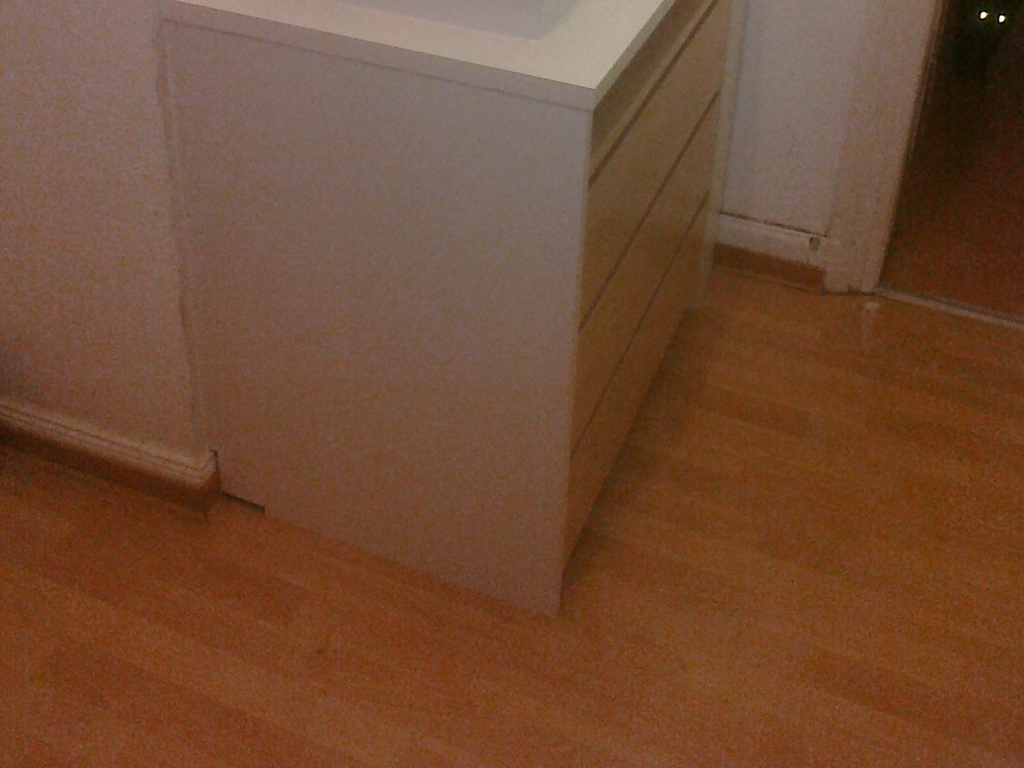What can be seen in this image?
A. Cabinet and floor
B. Colorful scenery
C. Detailed objects
Answer with the option's letter from the given choices directly. The image displays a section of an interior space, specifically A. Cabinet and floor, which can be clearly seen. The cabinet presents a minimalist design with flat cabinet fronts and a neutral color palette, and it stands against a wall with a similar color scheme for a harmonious look. The floor appears to be wooden, adding warmth to the room's aesthetic. 